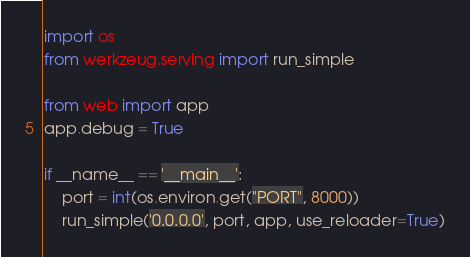<code> <loc_0><loc_0><loc_500><loc_500><_Python_>import os
from werkzeug.serving import run_simple

from web import app
app.debug = True

if __name__ == '__main__':
    port = int(os.environ.get("PORT", 8000))
    run_simple('0.0.0.0', port, app, use_reloader=True)
</code> 